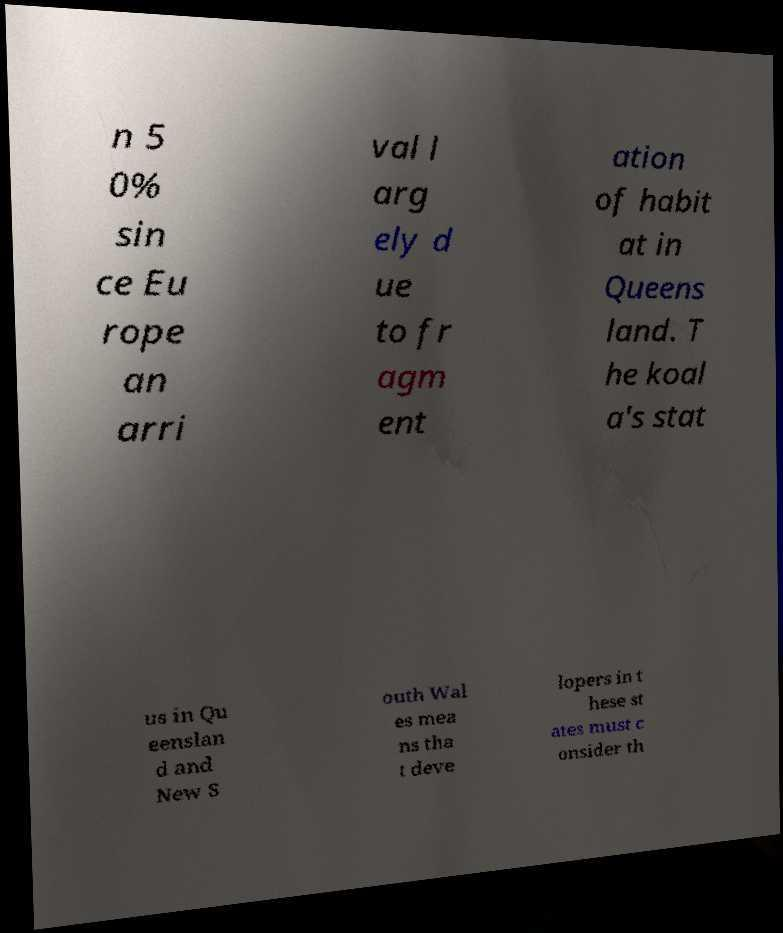There's text embedded in this image that I need extracted. Can you transcribe it verbatim? n 5 0% sin ce Eu rope an arri val l arg ely d ue to fr agm ent ation of habit at in Queens land. T he koal a's stat us in Qu eenslan d and New S outh Wal es mea ns tha t deve lopers in t hese st ates must c onsider th 